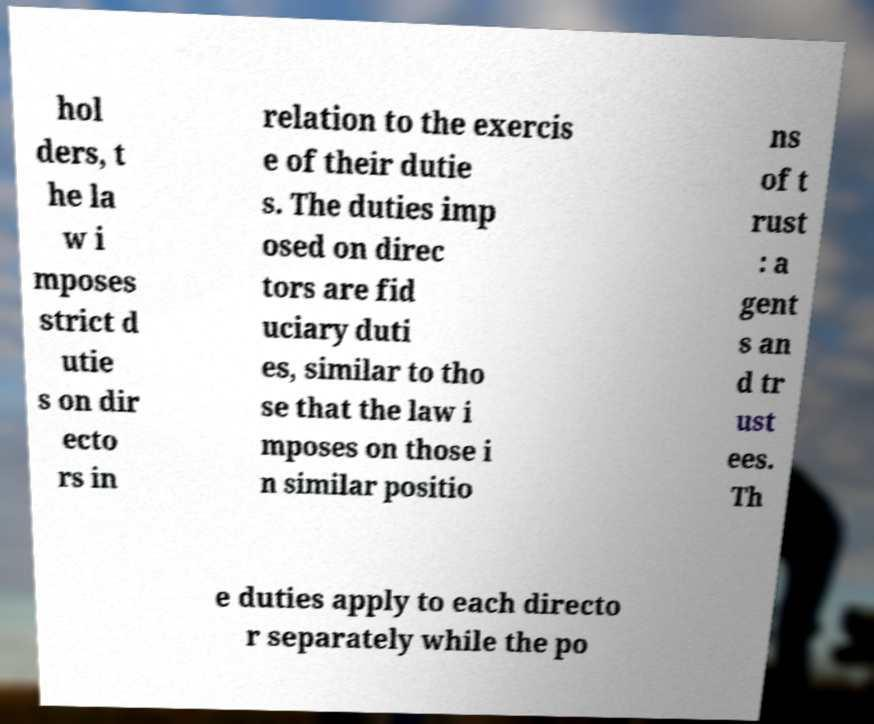For documentation purposes, I need the text within this image transcribed. Could you provide that? hol ders, t he la w i mposes strict d utie s on dir ecto rs in relation to the exercis e of their dutie s. The duties imp osed on direc tors are fid uciary duti es, similar to tho se that the law i mposes on those i n similar positio ns of t rust : a gent s an d tr ust ees. Th e duties apply to each directo r separately while the po 